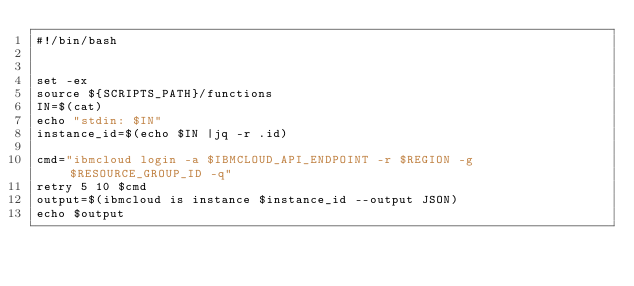Convert code to text. <code><loc_0><loc_0><loc_500><loc_500><_Bash_>#!/bin/bash


set -ex
source ${SCRIPTS_PATH}/functions
IN=$(cat)
echo "stdin: $IN"
instance_id=$(echo $IN |jq -r .id)

cmd="ibmcloud login -a $IBMCLOUD_API_ENDPOINT -r $REGION -g $RESOURCE_GROUP_ID -q"
retry 5 10 $cmd
output=$(ibmcloud is instance $instance_id --output JSON)
echo $output
</code> 